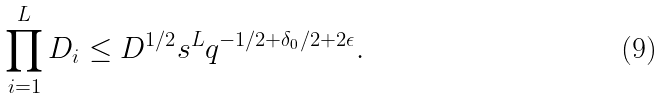<formula> <loc_0><loc_0><loc_500><loc_500>\prod _ { i = 1 } ^ { L } D _ { i } \leq D ^ { 1 / 2 } s ^ { L } q ^ { - 1 / 2 + \delta _ { 0 } / 2 + 2 \epsilon } .</formula> 